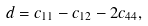Convert formula to latex. <formula><loc_0><loc_0><loc_500><loc_500>d = c _ { 1 1 } - c _ { 1 2 } - 2 c _ { 4 4 } ,</formula> 